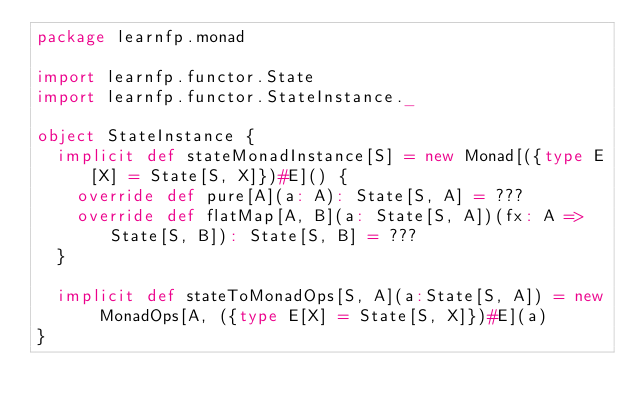Convert code to text. <code><loc_0><loc_0><loc_500><loc_500><_Scala_>package learnfp.monad

import learnfp.functor.State
import learnfp.functor.StateInstance._

object StateInstance {
  implicit def stateMonadInstance[S] = new Monad[({type E[X] = State[S, X]})#E]() {
    override def pure[A](a: A): State[S, A] = ???
    override def flatMap[A, B](a: State[S, A])(fx: A => State[S, B]): State[S, B] = ???
  }

  implicit def stateToMonadOps[S, A](a:State[S, A]) = new MonadOps[A, ({type E[X] = State[S, X]})#E](a)
}
</code> 